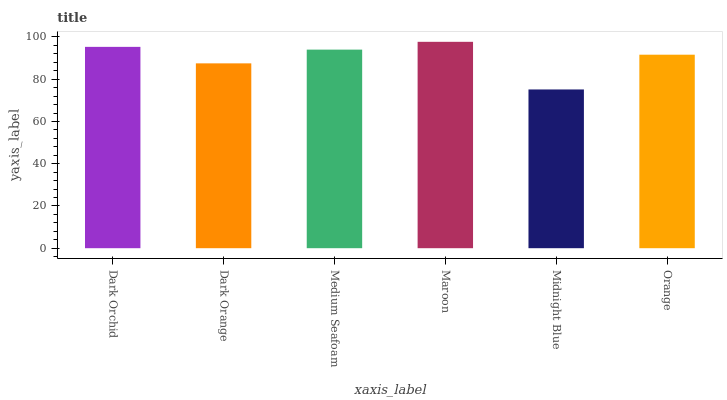Is Dark Orange the minimum?
Answer yes or no. No. Is Dark Orange the maximum?
Answer yes or no. No. Is Dark Orchid greater than Dark Orange?
Answer yes or no. Yes. Is Dark Orange less than Dark Orchid?
Answer yes or no. Yes. Is Dark Orange greater than Dark Orchid?
Answer yes or no. No. Is Dark Orchid less than Dark Orange?
Answer yes or no. No. Is Medium Seafoam the high median?
Answer yes or no. Yes. Is Orange the low median?
Answer yes or no. Yes. Is Maroon the high median?
Answer yes or no. No. Is Maroon the low median?
Answer yes or no. No. 